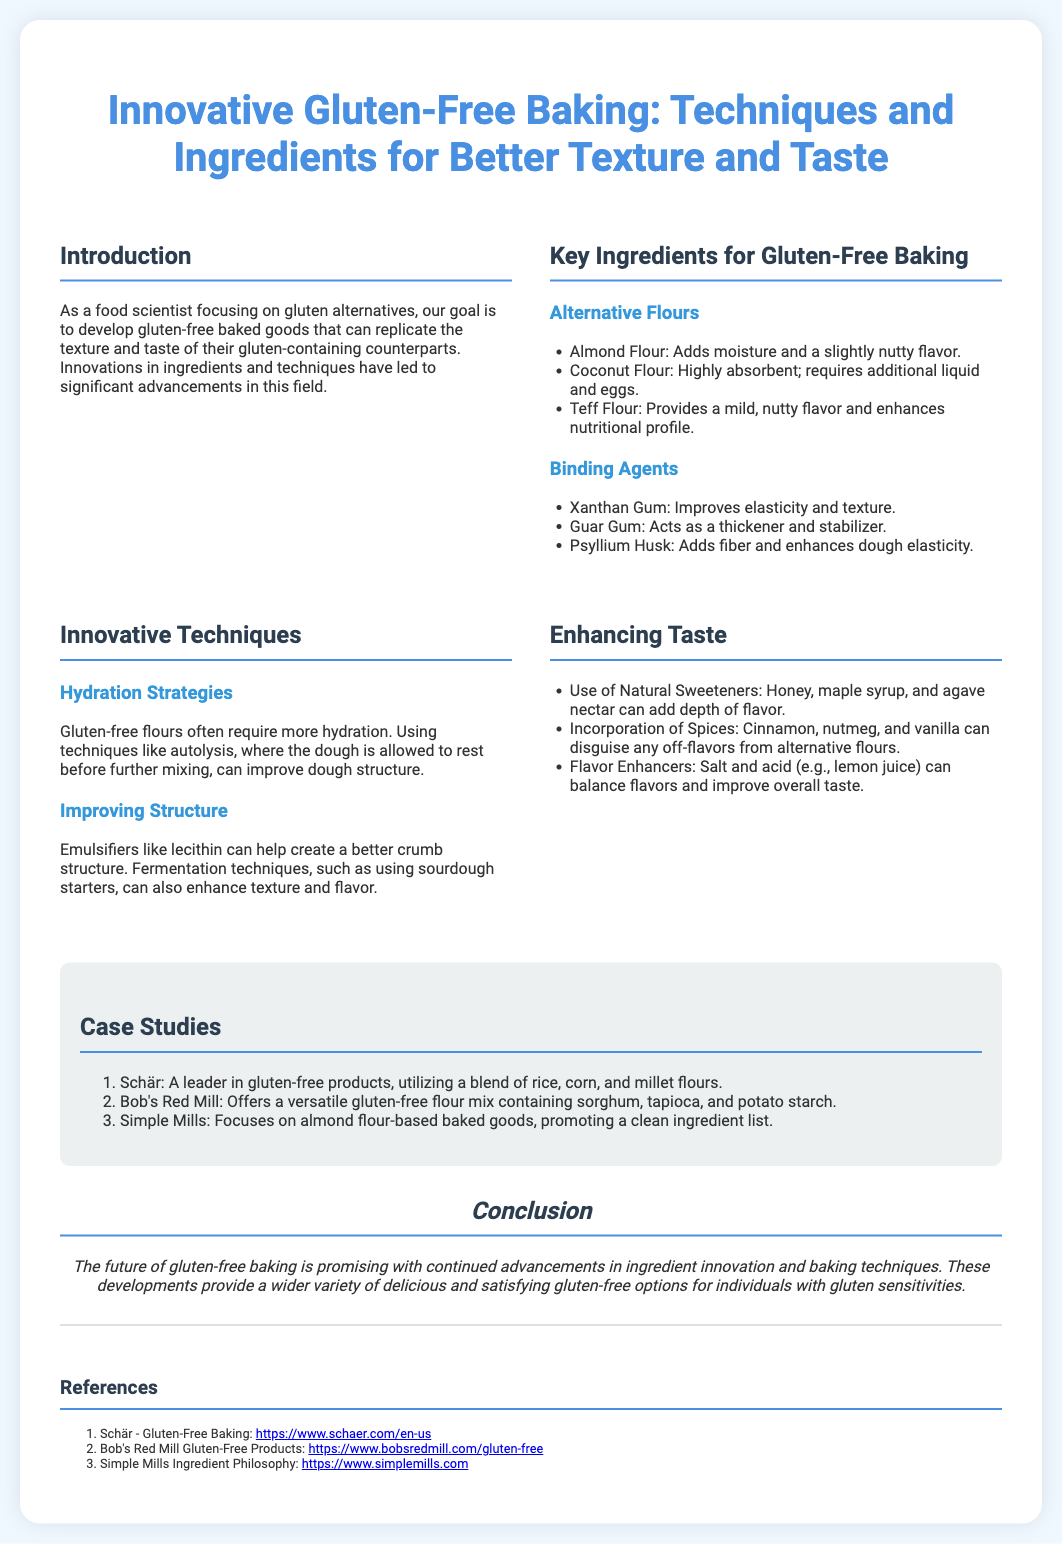What is the main goal of developing gluten-free baked goods? The goal is to replicate the texture and taste of gluten-containing counterparts.
Answer: Replicate texture and taste Name three alternative flours mentioned in the poster. The section on alternative flours lists almond flour, coconut flour, and teff flour.
Answer: Almond flour, coconut flour, teff flour What binding agent improves elasticity and texture? One of the binding agents listed that improves elasticity and texture is xanthan gum.
Answer: Xanthan gum Which natural sweeteners can enhance taste? The poster mentions honey, maple syrup, and agave nectar as natural sweeteners.
Answer: Honey, maple syrup, agave nectar How many case studies are presented in the document? There are three case studies showcased in the section.
Answer: Three What innovative technique is suggested for improving dough structure? The poster suggests using emulsifiers like lecithin to improve dough structure.
Answer: Emulsifiers like lecithin Which ingredient requires additional liquid and eggs? Coconut flour is noted for being highly absorbent and requiring additional liquid and eggs.
Answer: Coconut flour What is the conclusion regarding the future of gluten-free baking? The conclusion states that the future of gluten-free baking is promising with advancements in ingredients and techniques.
Answer: Promising future 